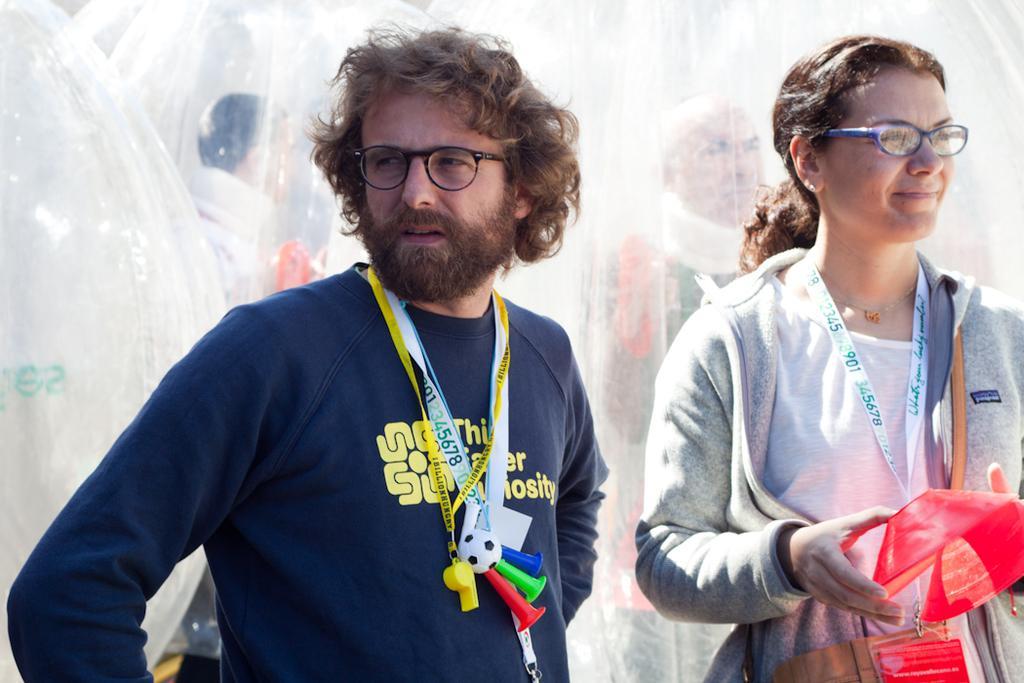Describe this image in one or two sentences. In this image in the center there is one man who is standing, and on the right side there is one woman who is standing and she is holding one box and these two are wearing some tags. In the background there are some air balloons and some persons. 